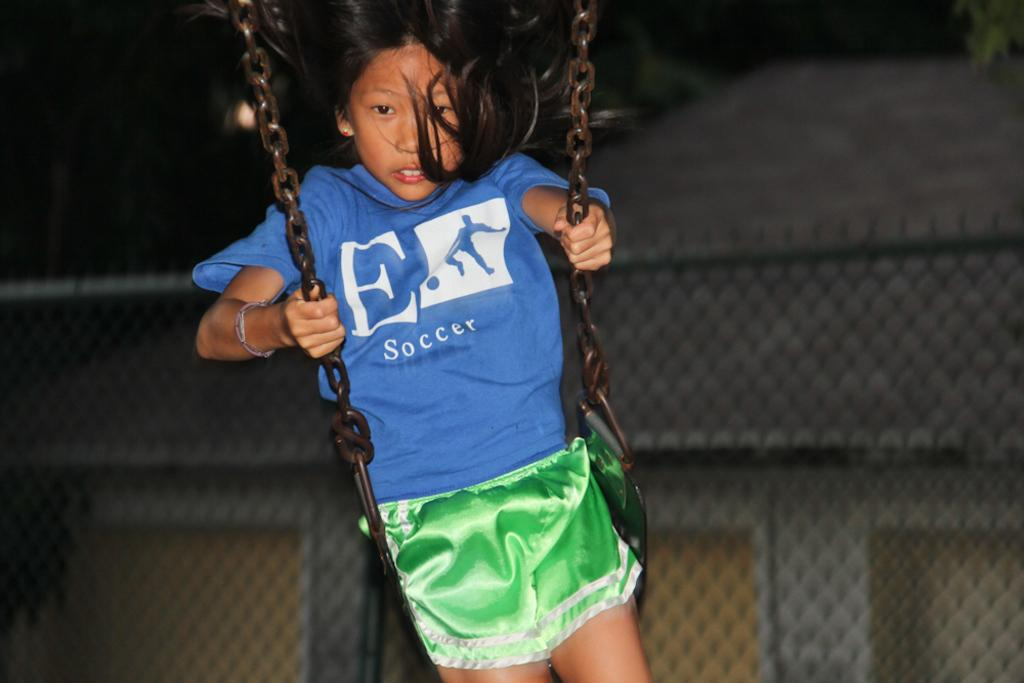<image>
Write a terse but informative summary of the picture. Girl on a swing with a blue shirt that has soccer in white letters on the front. 